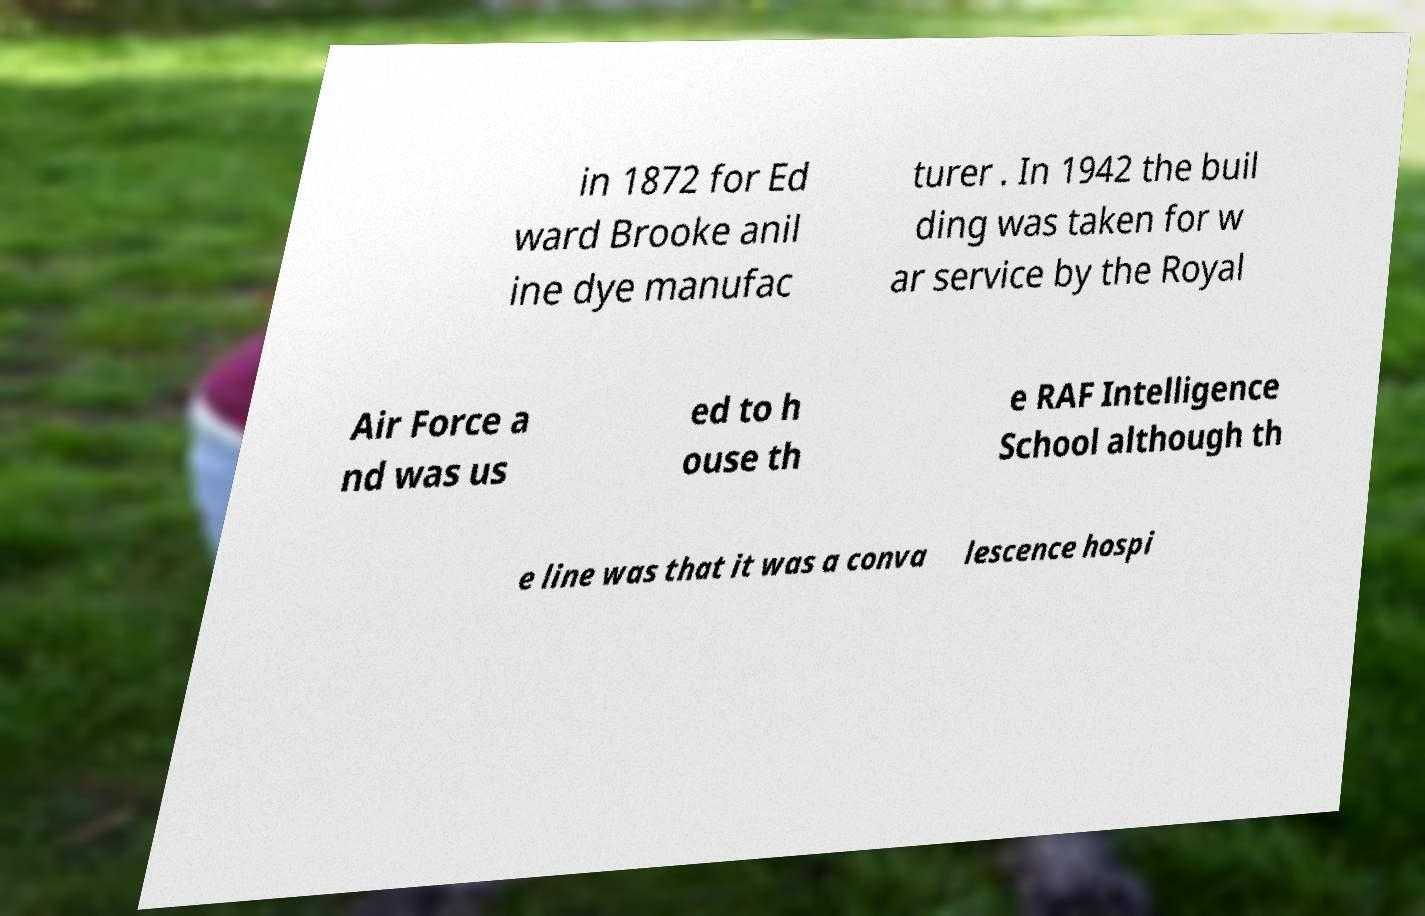What messages or text are displayed in this image? I need them in a readable, typed format. in 1872 for Ed ward Brooke anil ine dye manufac turer . In 1942 the buil ding was taken for w ar service by the Royal Air Force a nd was us ed to h ouse th e RAF Intelligence School although th e line was that it was a conva lescence hospi 